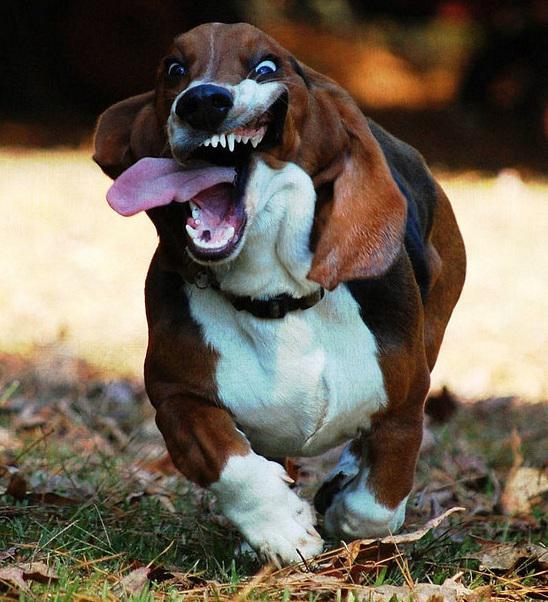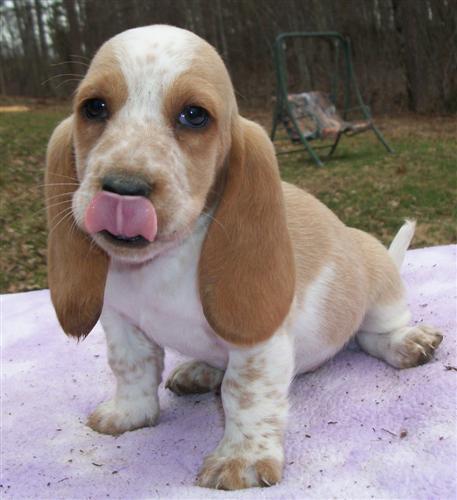The first image is the image on the left, the second image is the image on the right. Assess this claim about the two images: "An image shows two basset hounds side-by-side outdoors, and at least one has its loose jowls flapping.". Correct or not? Answer yes or no. No. The first image is the image on the left, the second image is the image on the right. For the images shown, is this caption "There are three dogs." true? Answer yes or no. No. 